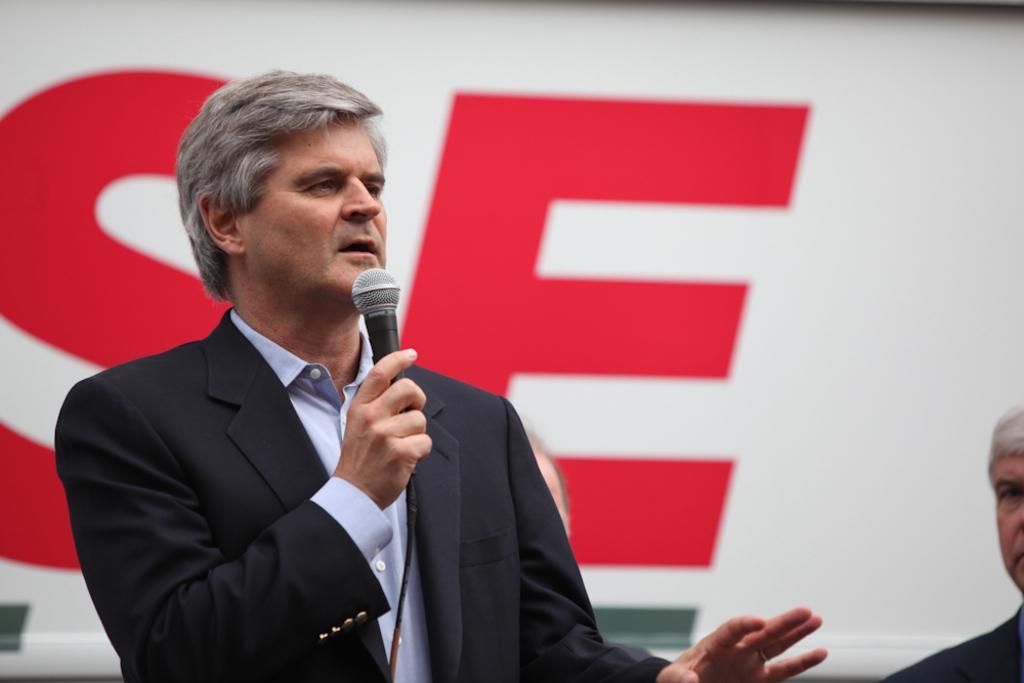In one or two sentences, can you explain what this image depicts? in the image in the center we can see one man standing and he is holding the microphone. And coming to the background we can see the banner. 